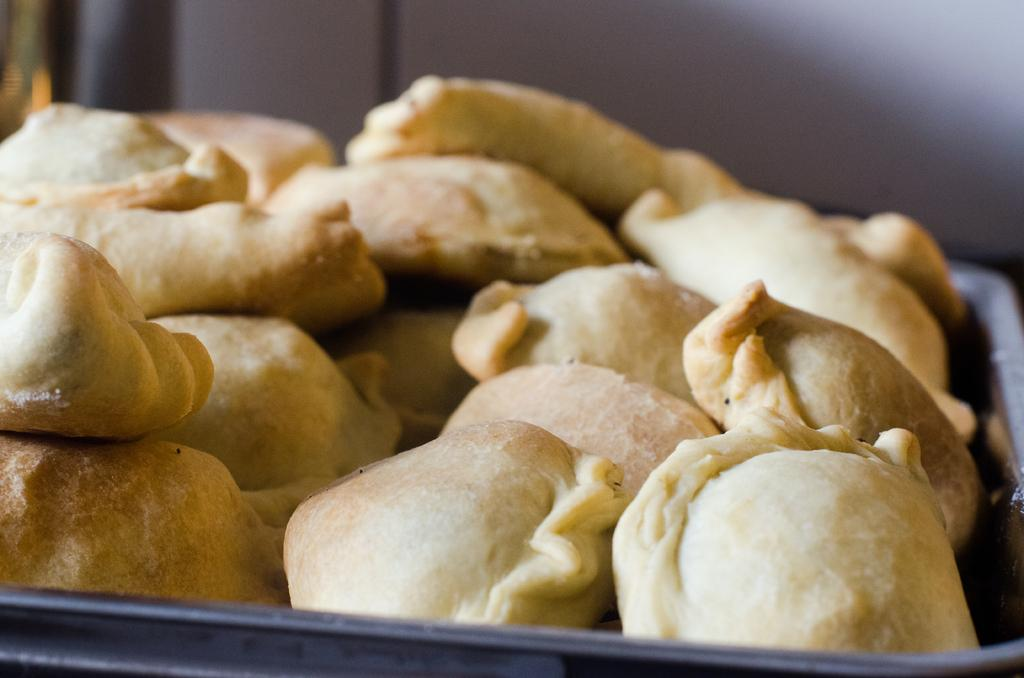What is the main subject of the image? The main subject of the image is not clear from the provided facts. Are there any food items visible in the image? The transcript mentions food items on a tree, which seems out of context or might have resulted from a transcription error. Can you describe any other objects or elements in the image? The provided facts do not mention any other objects or elements in the image. What type of rail can be seen connecting the food items on the tree in the image? There is no mention of a rail or food items on a tree in the provided facts, so it is not possible to answer that question. 